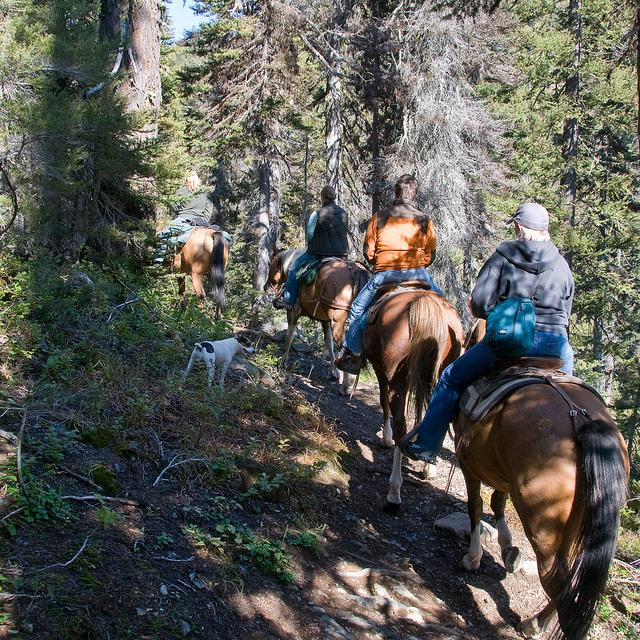Why are some trees here leafless?

Choices:
A) they're dead
B) spring
C) sap suckers
D) summer they're dead 